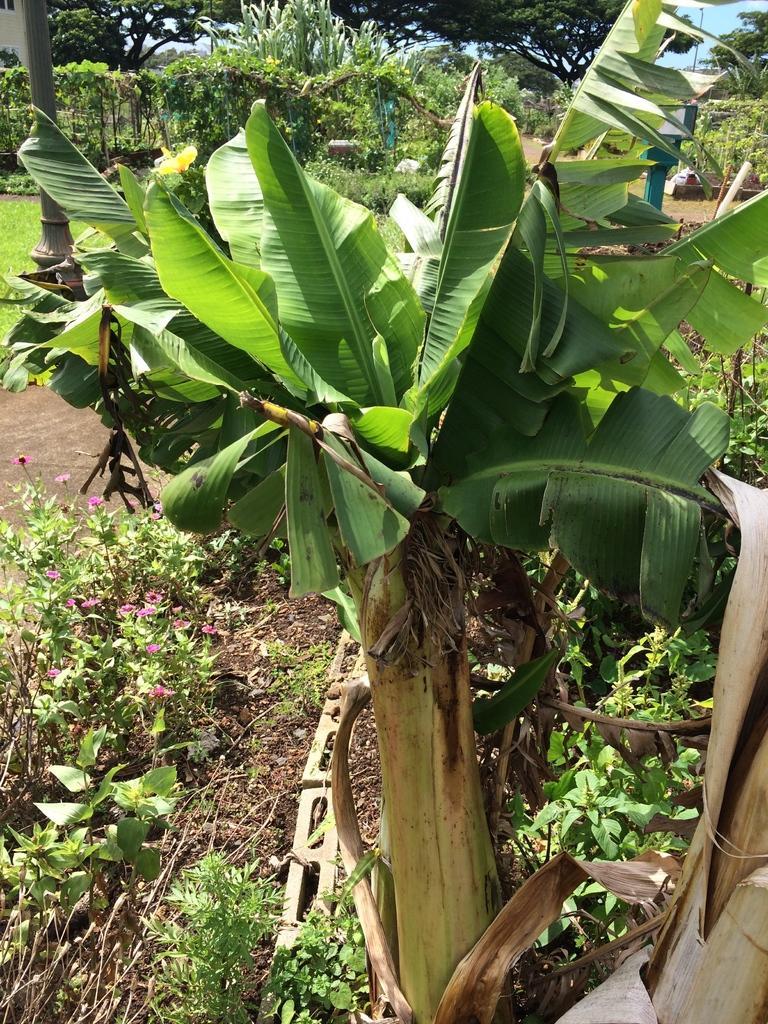Could you give a brief overview of what you see in this image? In the foreground of this picture, there is a tree and in the background, there are plants, flowers, trees, path, pole, and the grass. 